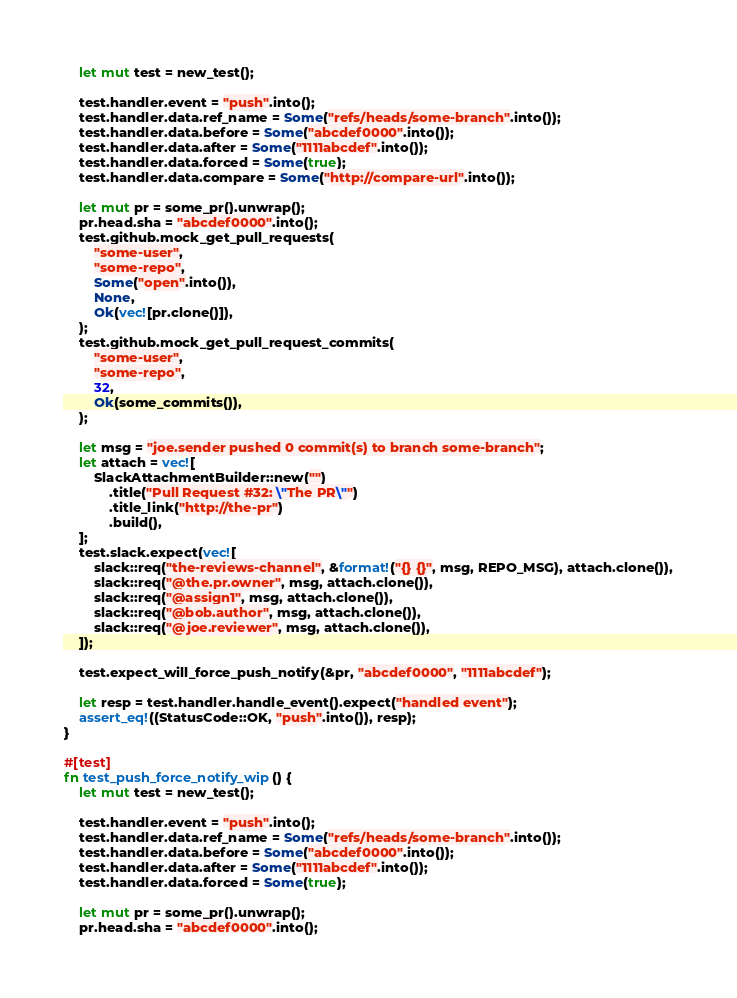<code> <loc_0><loc_0><loc_500><loc_500><_Rust_>    let mut test = new_test();

    test.handler.event = "push".into();
    test.handler.data.ref_name = Some("refs/heads/some-branch".into());
    test.handler.data.before = Some("abcdef0000".into());
    test.handler.data.after = Some("1111abcdef".into());
    test.handler.data.forced = Some(true);
    test.handler.data.compare = Some("http://compare-url".into());

    let mut pr = some_pr().unwrap();
    pr.head.sha = "abcdef0000".into();
    test.github.mock_get_pull_requests(
        "some-user",
        "some-repo",
        Some("open".into()),
        None,
        Ok(vec![pr.clone()]),
    );
    test.github.mock_get_pull_request_commits(
        "some-user",
        "some-repo",
        32,
        Ok(some_commits()),
    );

    let msg = "joe.sender pushed 0 commit(s) to branch some-branch";
    let attach = vec![
        SlackAttachmentBuilder::new("")
            .title("Pull Request #32: \"The PR\"")
            .title_link("http://the-pr")
            .build(),
    ];
    test.slack.expect(vec![
        slack::req("the-reviews-channel", &format!("{} {}", msg, REPO_MSG), attach.clone()),
        slack::req("@the.pr.owner", msg, attach.clone()),
        slack::req("@assign1", msg, attach.clone()),
        slack::req("@bob.author", msg, attach.clone()),
        slack::req("@joe.reviewer", msg, attach.clone()),
    ]);

    test.expect_will_force_push_notify(&pr, "abcdef0000", "1111abcdef");

    let resp = test.handler.handle_event().expect("handled event");
    assert_eq!((StatusCode::OK, "push".into()), resp);
}

#[test]
fn test_push_force_notify_wip() {
    let mut test = new_test();

    test.handler.event = "push".into();
    test.handler.data.ref_name = Some("refs/heads/some-branch".into());
    test.handler.data.before = Some("abcdef0000".into());
    test.handler.data.after = Some("1111abcdef".into());
    test.handler.data.forced = Some(true);

    let mut pr = some_pr().unwrap();
    pr.head.sha = "abcdef0000".into();</code> 